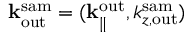<formula> <loc_0><loc_0><loc_500><loc_500>{ k } _ { o u t } ^ { s a m } = ( { k } _ { \| } ^ { o u t } , k _ { z , o u t } ^ { s a m } )</formula> 